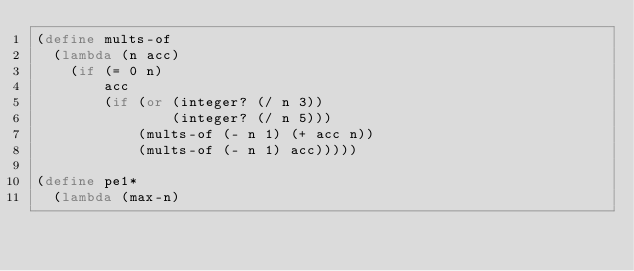Convert code to text. <code><loc_0><loc_0><loc_500><loc_500><_Scheme_>(define mults-of
	(lambda (n acc)
		(if (= 0 n)
				acc
				(if (or (integer? (/ n 3))
								(integer? (/ n 5)))
						(mults-of (- n 1) (+ acc n))
						(mults-of (- n 1) acc)))))

(define pe1*
	(lambda (max-n)</code> 